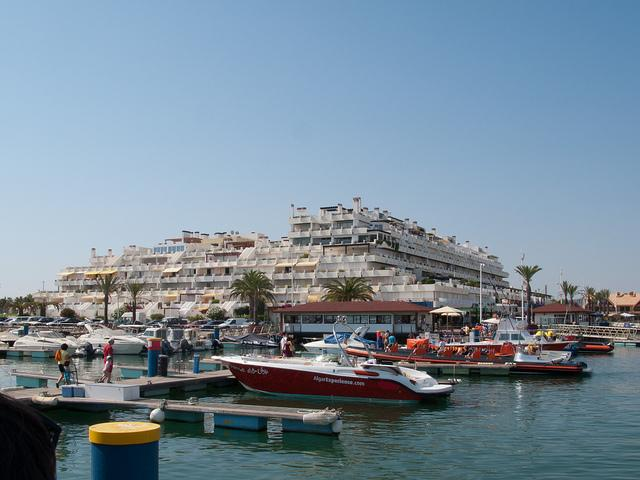What does the side of the nearest boat want you to visit? website 